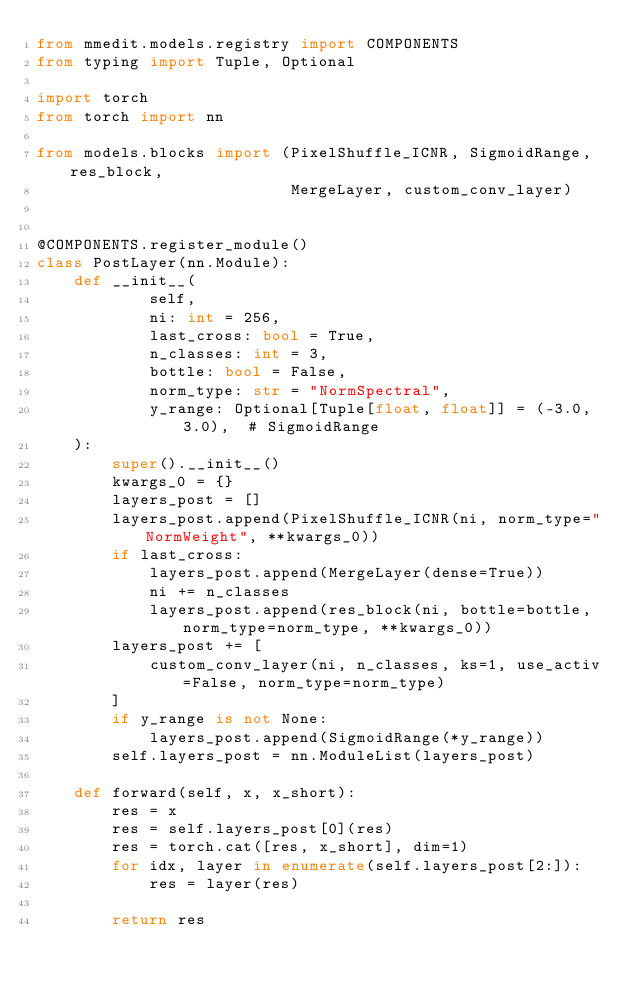<code> <loc_0><loc_0><loc_500><loc_500><_Python_>from mmedit.models.registry import COMPONENTS
from typing import Tuple, Optional

import torch
from torch import nn

from models.blocks import (PixelShuffle_ICNR, SigmoidRange, res_block,
                           MergeLayer, custom_conv_layer)


@COMPONENTS.register_module()
class PostLayer(nn.Module):
    def __init__(
            self,
            ni: int = 256,
            last_cross: bool = True,
            n_classes: int = 3,
            bottle: bool = False,
            norm_type: str = "NormSpectral",
            y_range: Optional[Tuple[float, float]] = (-3.0, 3.0),  # SigmoidRange
    ):
        super().__init__()
        kwargs_0 = {}
        layers_post = []
        layers_post.append(PixelShuffle_ICNR(ni, norm_type="NormWeight", **kwargs_0))
        if last_cross:
            layers_post.append(MergeLayer(dense=True))
            ni += n_classes
            layers_post.append(res_block(ni, bottle=bottle, norm_type=norm_type, **kwargs_0))
        layers_post += [
            custom_conv_layer(ni, n_classes, ks=1, use_activ=False, norm_type=norm_type)
        ]
        if y_range is not None:
            layers_post.append(SigmoidRange(*y_range))
        self.layers_post = nn.ModuleList(layers_post)

    def forward(self, x, x_short):
        res = x
        res = self.layers_post[0](res)
        res = torch.cat([res, x_short], dim=1)
        for idx, layer in enumerate(self.layers_post[2:]):
            res = layer(res)

        return res

</code> 